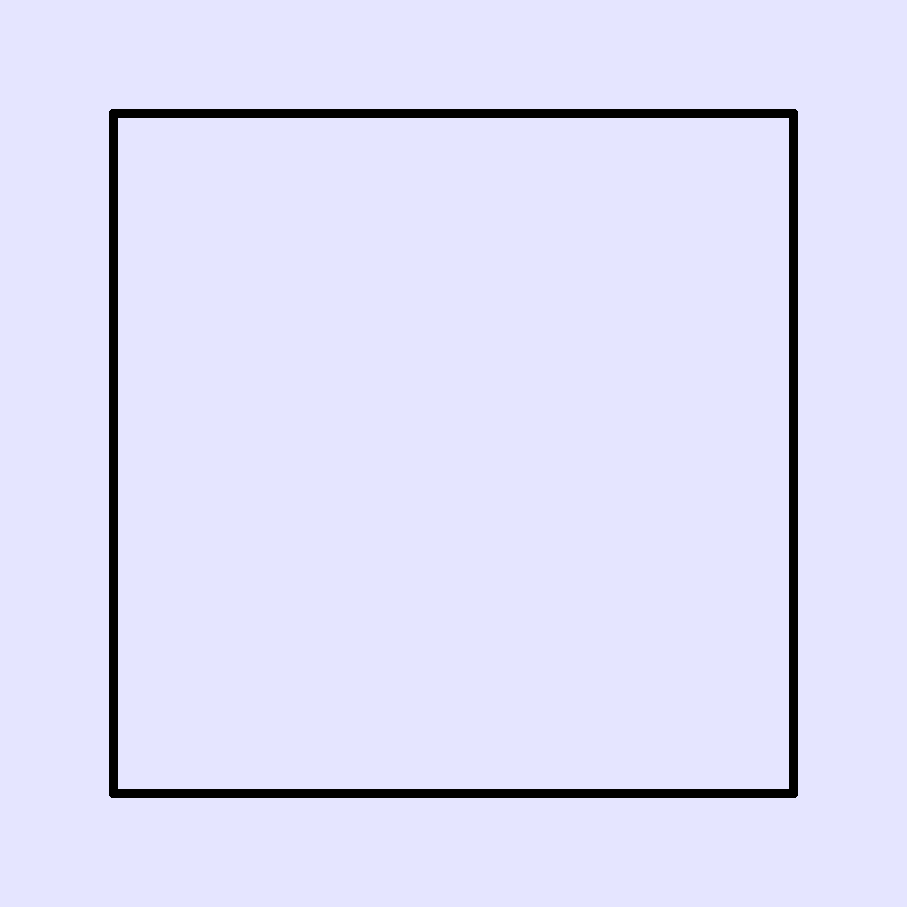In David Lord's latest epic battle scene, the protagonist wears enchanted Dragonscale Armor. If the armor experiences three simultaneous impact forces during combat - F1 (vertical), F2 (horizontal), and F3 (diagonal) - which force is likely to cause the most damage, and why? To determine which force is likely to cause the most damage, we need to consider the properties of Dragonscale Armor and the nature of the impact forces:

1. Dragonscale Armor characteristics:
   - Composed of overlapping scales
   - Strongest against vertical impacts
   - Moderately strong against horizontal impacts
   - Weakest against diagonal impacts

2. Analysis of impact forces:
   - F1 (vertical): The overlapping scales are designed to deflect vertical impacts effectively. The force is distributed across multiple scales, reducing the overall impact.
   - F2 (horizontal): The armor provides moderate protection against horizontal forces. The scales may shift slightly, absorbing some of the impact.
   - F3 (diagonal): This force strikes at an angle where the scales are most vulnerable. It can potentially slip between the scales or cause them to separate.

3. Force comparison:
   - F1 is likely to cause the least damage due to the armor's strength against vertical impacts.
   - F2 will cause moderate damage, as the armor is designed to handle horizontal forces reasonably well.
   - F3 has the highest potential for damage, as it exploits the weakness in the scale arrangement.

4. Magical considerations:
   - The enchantment on the armor may provide additional protection, but it's unlikely to completely negate the inherent structural vulnerabilities.

Given these factors, F3 (the diagonal force) is most likely to cause the most damage to the Dragonscale Armor.
Answer: F3 (diagonal force) 